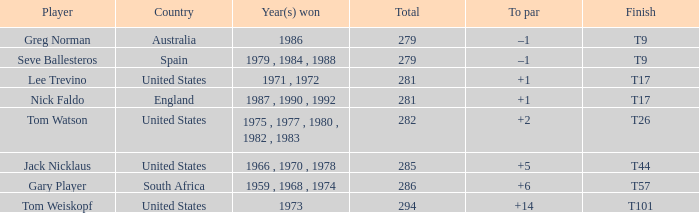In which country was greg norman born? Australia. 